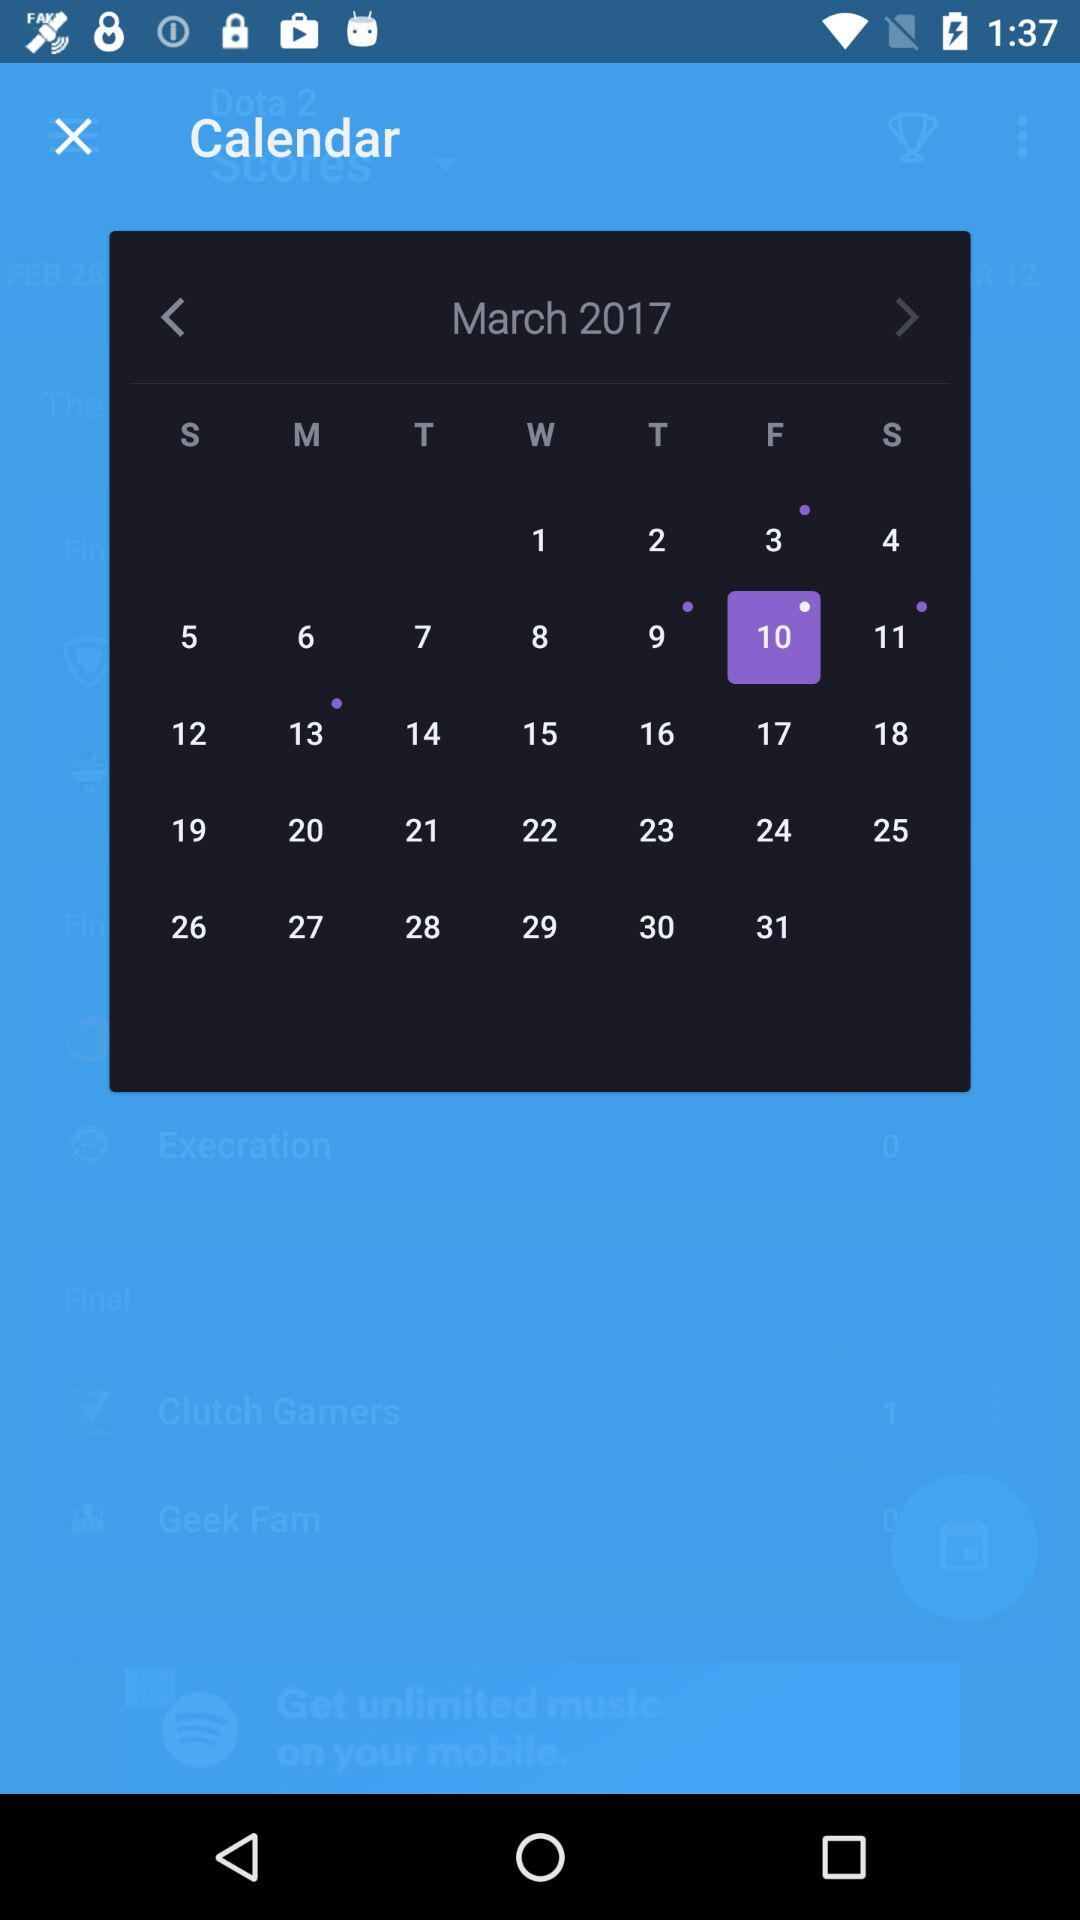What is the selected date? The selected date is Friday, March 10, 2017. 